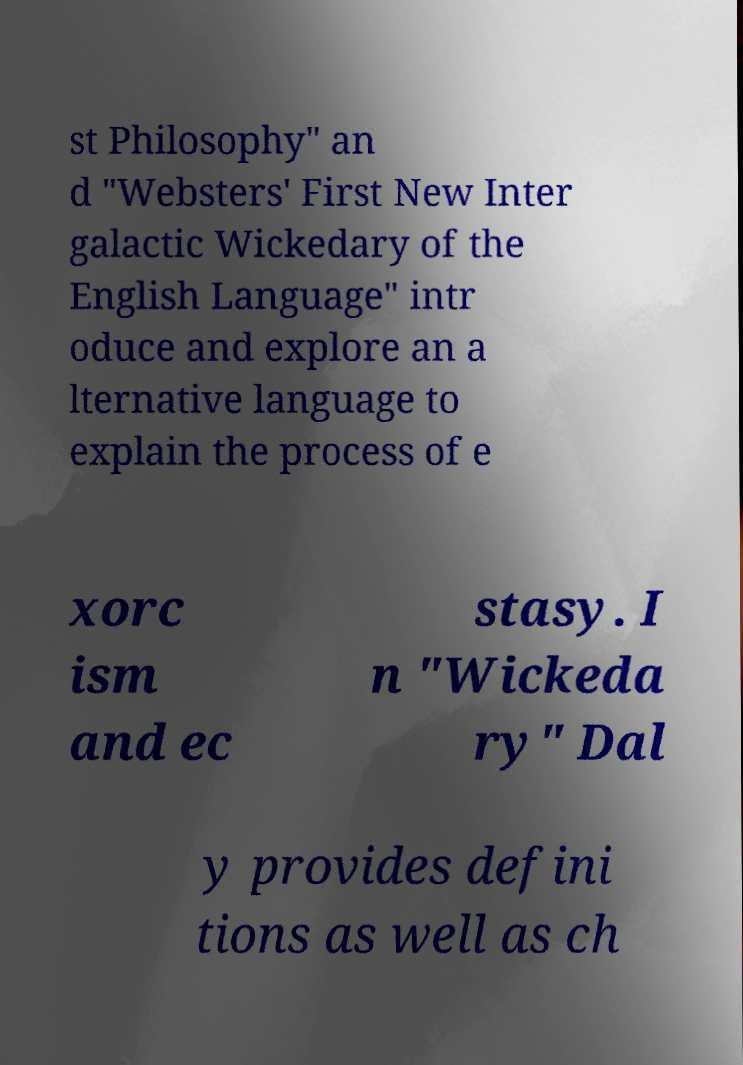Can you accurately transcribe the text from the provided image for me? st Philosophy" an d "Websters' First New Inter galactic Wickedary of the English Language" intr oduce and explore an a lternative language to explain the process of e xorc ism and ec stasy. I n "Wickeda ry" Dal y provides defini tions as well as ch 